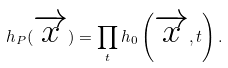<formula> <loc_0><loc_0><loc_500><loc_500>h _ { P } ( \overrightarrow { x } ) = \prod _ { t } h _ { 0 } \left ( \overrightarrow { x } , t \right ) .</formula> 